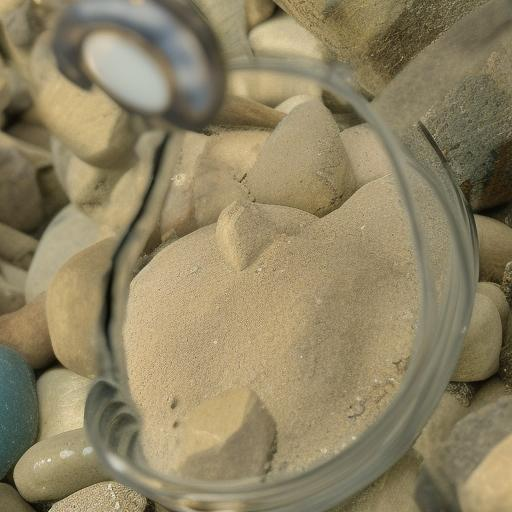What is the purpose of the magnifying glass in the composition of this image? The magnifying glass in the image serves both a functional and symbolic purpose. Functionally, it offers a closer look at the texture of the sand, highlighting the intricate details and fine grains that might otherwise go unnoticed. Symbolically, it can represent the idea of searching, examining, or discovering something hidden or not immediately apparent in the broader context, inviting the viewer to take a closer look at mundane objects to find beauty or significance. 